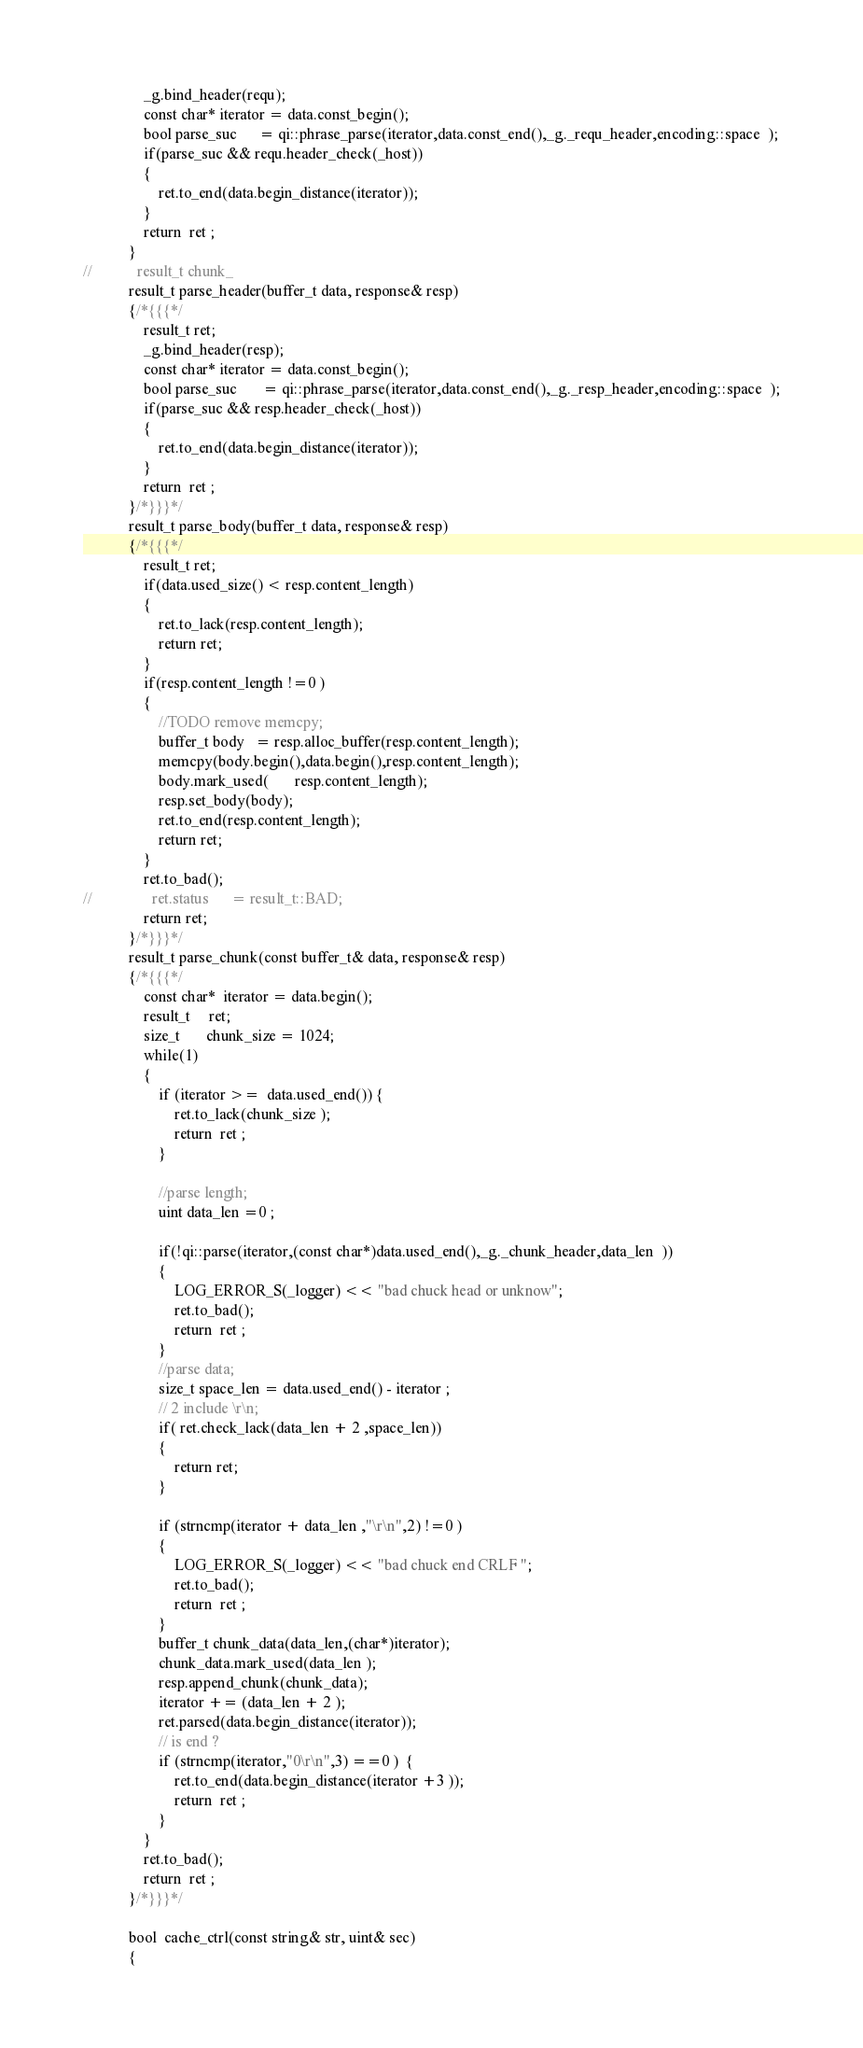Convert code to text. <code><loc_0><loc_0><loc_500><loc_500><_C++_>                _g.bind_header(requ);
                const char* iterator = data.const_begin();
                bool parse_suc      = qi::phrase_parse(iterator,data.const_end(),_g._requ_header,encoding::space  );
                if(parse_suc && requ.header_check(_host))
                {
                    ret.to_end(data.begin_distance(iterator));
                }
                return  ret ;
            }
//            result_t chunk_
            result_t parse_header(buffer_t data, response& resp)
            {/*{{{*/
                result_t ret;
                _g.bind_header(resp);
                const char* iterator = data.const_begin();
                bool parse_suc       = qi::phrase_parse(iterator,data.const_end(),_g._resp_header,encoding::space  );
                if(parse_suc && resp.header_check(_host))
                {
                    ret.to_end(data.begin_distance(iterator));
                }
                return  ret ;
            }/*}}}*/
            result_t parse_body(buffer_t data, response& resp)
            {/*{{{*/
                result_t ret;
                if(data.used_size() < resp.content_length)
                {
                    ret.to_lack(resp.content_length);
                    return ret;
                }
                if(resp.content_length !=0 )
                {
                    //TODO remove memcpy;
                    buffer_t body   = resp.alloc_buffer(resp.content_length);
                    memcpy(body.begin(),data.begin(),resp.content_length);
                    body.mark_used(       resp.content_length);
                    resp.set_body(body);
                    ret.to_end(resp.content_length);
                    return ret;
                }
                ret.to_bad();
//                ret.status      = result_t::BAD;
                return ret;
            }/*}}}*/
            result_t parse_chunk(const buffer_t& data, response& resp)
            {/*{{{*/
                const char*  iterator = data.begin();
                result_t     ret;
                size_t       chunk_size = 1024;
                while(1)
                {
                    if (iterator >=  data.used_end()) {
                        ret.to_lack(chunk_size );
                        return  ret ;
                    }

                    //parse length;
                    uint data_len =0 ;

                    if(!qi::parse(iterator,(const char*)data.used_end(),_g._chunk_header,data_len  ))
                    {
                        LOG_ERROR_S(_logger) << "bad chuck head or unknow"; 
                        ret.to_bad();
                        return  ret ;
                    }
                    //parse data;
                    size_t space_len = data.used_end() - iterator ;
                    // 2 include \r\n;
                    if( ret.check_lack(data_len + 2 ,space_len))
                    {
                        return ret;
                    }

                    if (strncmp(iterator + data_len ,"\r\n",2) !=0 )   
                    {
                        LOG_ERROR_S(_logger) << "bad chuck end CRLF "; 
                        ret.to_bad();
                        return  ret ;
                    }
                    buffer_t chunk_data(data_len,(char*)iterator);
                    chunk_data.mark_used(data_len );
                    resp.append_chunk(chunk_data);
                    iterator += (data_len + 2 );
                    ret.parsed(data.begin_distance(iterator));
                    // is end ?
                    if (strncmp(iterator,"0\r\n",3) ==0 )  {
                        ret.to_end(data.begin_distance(iterator +3 ));
                        return  ret ;
                    }
                }
                ret.to_bad();
                return  ret ;
            }/*}}}*/

            bool  cache_ctrl(const string& str, uint& sec)
            {</code> 